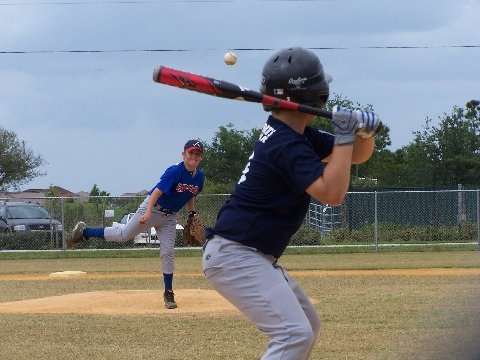Describe the objects in this image and their specific colors. I can see people in lavender, black, darkgray, and gray tones, people in lavender, gray, black, navy, and darkgray tones, baseball bat in lavender, black, maroon, gray, and brown tones, car in lavender, gray, and black tones, and baseball glove in lavender, black, maroon, and brown tones in this image. 